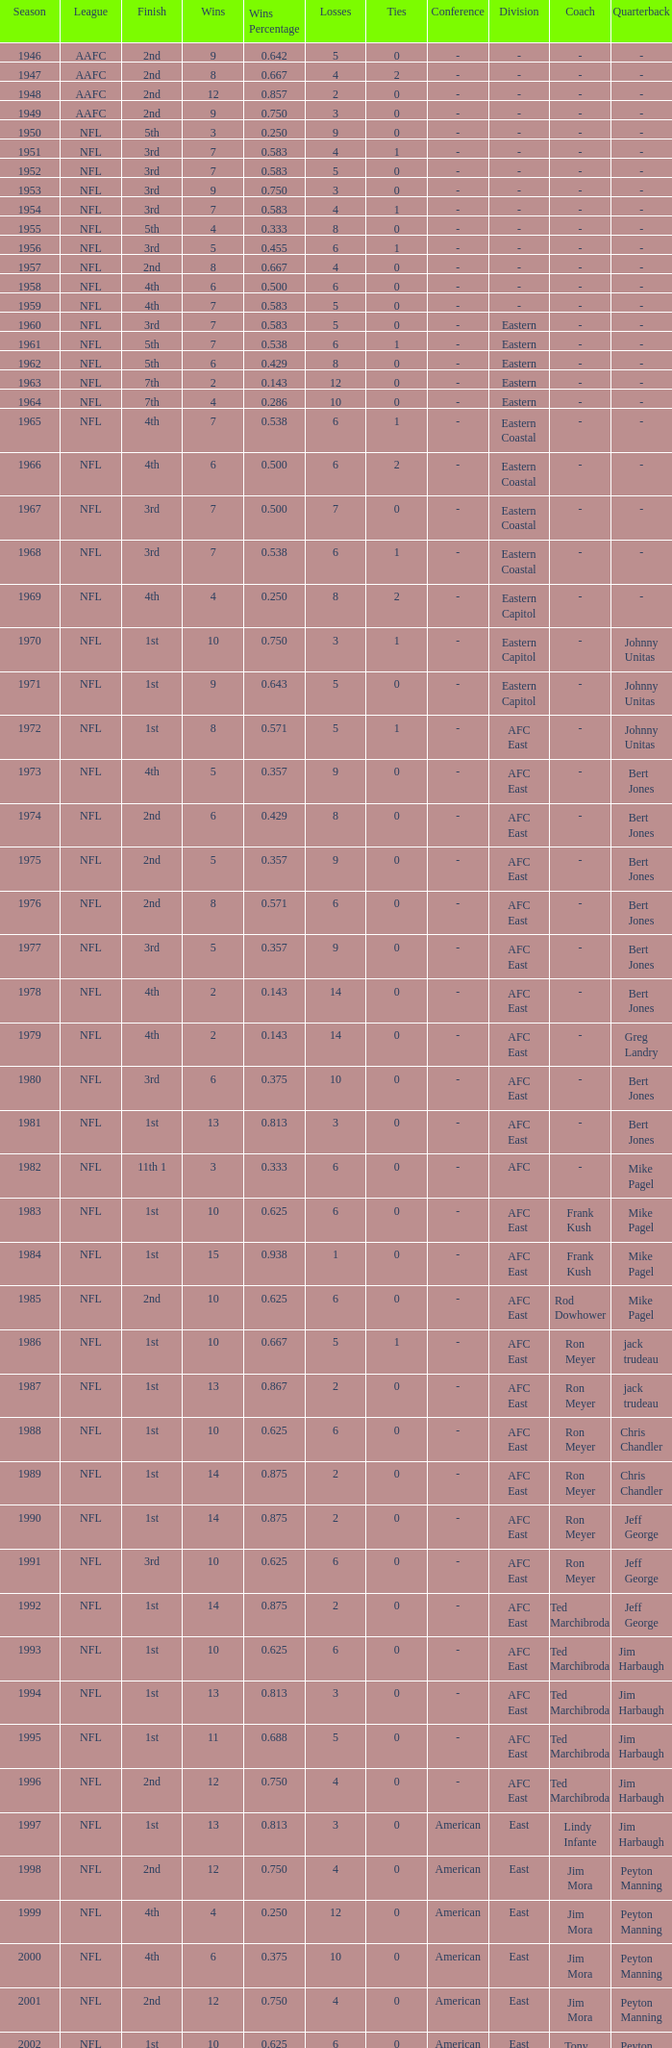What is the highest wins for the NFL with a finish of 1st, and more than 6 losses? None. 